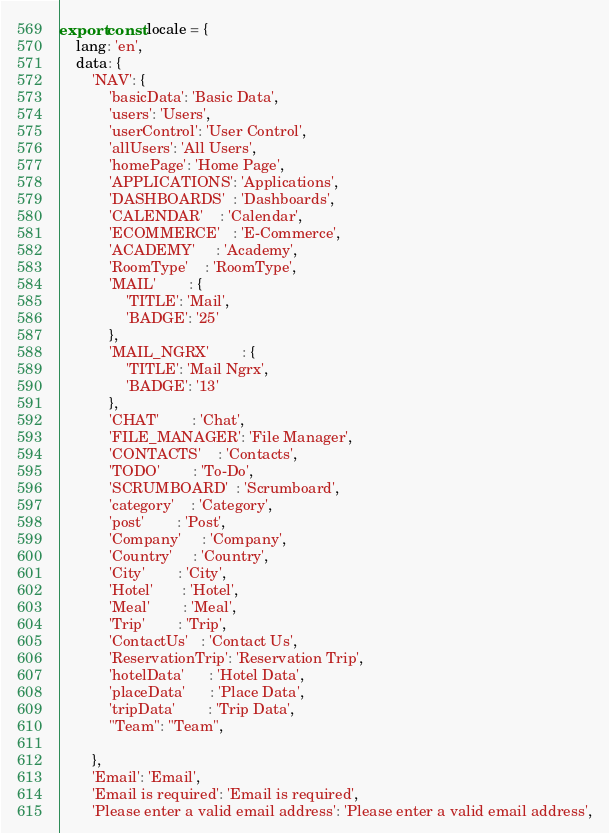Convert code to text. <code><loc_0><loc_0><loc_500><loc_500><_TypeScript_>export const locale = {
    lang: 'en',
    data: {
        'NAV': {
            'basicData': 'Basic Data',
            'users': 'Users',
            'userControl': 'User Control',
            'allUsers': 'All Users',
            'homePage': 'Home Page',
            'APPLICATIONS': 'Applications',
            'DASHBOARDS'  : 'Dashboards',
            'CALENDAR'    : 'Calendar',
            'ECOMMERCE'   : 'E-Commerce',
            'ACADEMY'     : 'Academy',
            'RoomType'    : 'RoomType',
            'MAIL'        : {
                'TITLE': 'Mail',
                'BADGE': '25'
            },
            'MAIL_NGRX'        : {
                'TITLE': 'Mail Ngrx',
                'BADGE': '13'
            },
            'CHAT'        : 'Chat',
            'FILE_MANAGER': 'File Manager',
            'CONTACTS'    : 'Contacts',
            'TODO'        : 'To-Do',
            'SCRUMBOARD'  : 'Scrumboard',
            'category'    : 'Category',
            'post'        : 'Post',
            'Company'     : 'Company',
            'Country'     : 'Country',
            'City'        : 'City',
            'Hotel'       : 'Hotel',
            'Meal'        : 'Meal',
            'Trip'        : 'Trip',
            'ContactUs'   : 'Contact Us',
            'ReservationTrip': 'Reservation Trip',
            'hotelData'      : 'Hotel Data',
            'placeData'      : 'Place Data',
            'tripData'        : 'Trip Data',
            "Team": "Team",

        },
        'Email': 'Email',
        'Email is required': 'Email is required',
        'Please enter a valid email address': 'Please enter a valid email address',</code> 